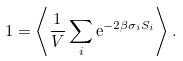Convert formula to latex. <formula><loc_0><loc_0><loc_500><loc_500>1 = \left \langle \frac { 1 } { V } \sum _ { i } { \mathrm e } ^ { - 2 \beta \sigma _ { i } S _ { i } } \right \rangle .</formula> 